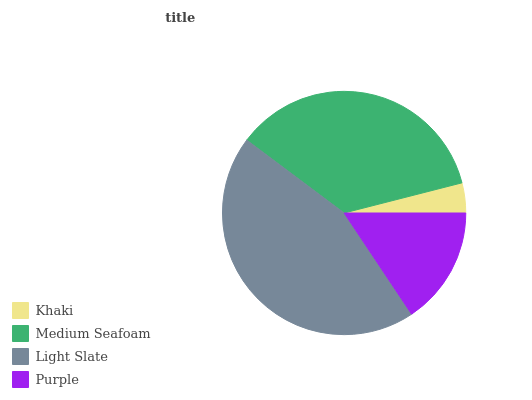Is Khaki the minimum?
Answer yes or no. Yes. Is Light Slate the maximum?
Answer yes or no. Yes. Is Medium Seafoam the minimum?
Answer yes or no. No. Is Medium Seafoam the maximum?
Answer yes or no. No. Is Medium Seafoam greater than Khaki?
Answer yes or no. Yes. Is Khaki less than Medium Seafoam?
Answer yes or no. Yes. Is Khaki greater than Medium Seafoam?
Answer yes or no. No. Is Medium Seafoam less than Khaki?
Answer yes or no. No. Is Medium Seafoam the high median?
Answer yes or no. Yes. Is Purple the low median?
Answer yes or no. Yes. Is Light Slate the high median?
Answer yes or no. No. Is Medium Seafoam the low median?
Answer yes or no. No. 